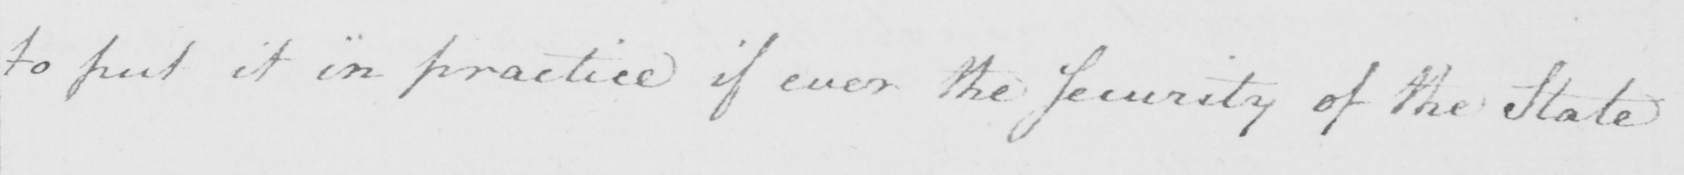Please transcribe the handwritten text in this image. to put it in practice if ever the Security of the State 